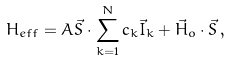Convert formula to latex. <formula><loc_0><loc_0><loc_500><loc_500>H _ { e f f } = A { \vec { S } } \cdot \sum _ { k = 1 } ^ { N } c _ { k } { \vec { I } } _ { k } + { \vec { H } } _ { o } \cdot { \vec { S } } \, ,</formula> 